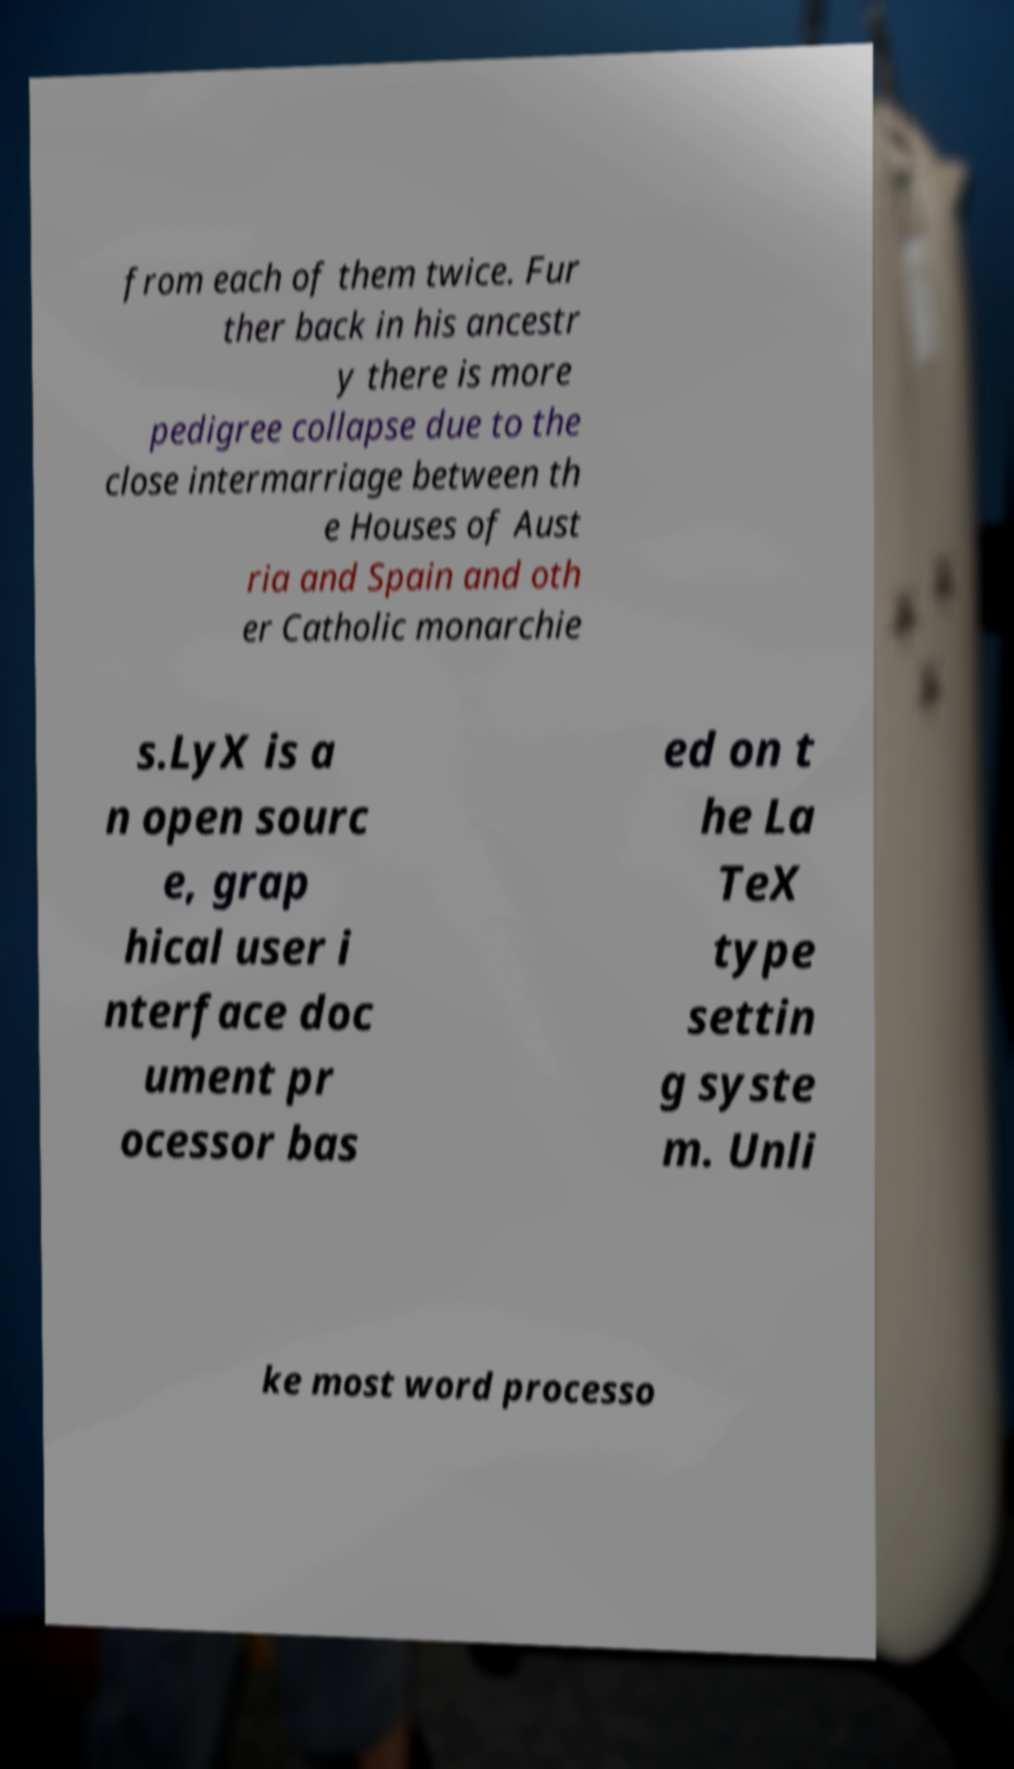Could you assist in decoding the text presented in this image and type it out clearly? from each of them twice. Fur ther back in his ancestr y there is more pedigree collapse due to the close intermarriage between th e Houses of Aust ria and Spain and oth er Catholic monarchie s.LyX is a n open sourc e, grap hical user i nterface doc ument pr ocessor bas ed on t he La TeX type settin g syste m. Unli ke most word processo 